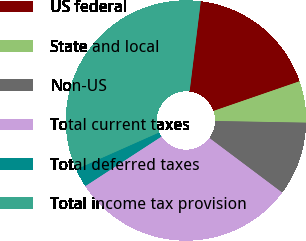Convert chart to OTSL. <chart><loc_0><loc_0><loc_500><loc_500><pie_chart><fcel>US federal<fcel>State and local<fcel>Non-US<fcel>Total current taxes<fcel>Total deferred taxes<fcel>Total income tax provision<nl><fcel>17.75%<fcel>5.58%<fcel>9.95%<fcel>30.57%<fcel>2.53%<fcel>33.62%<nl></chart> 